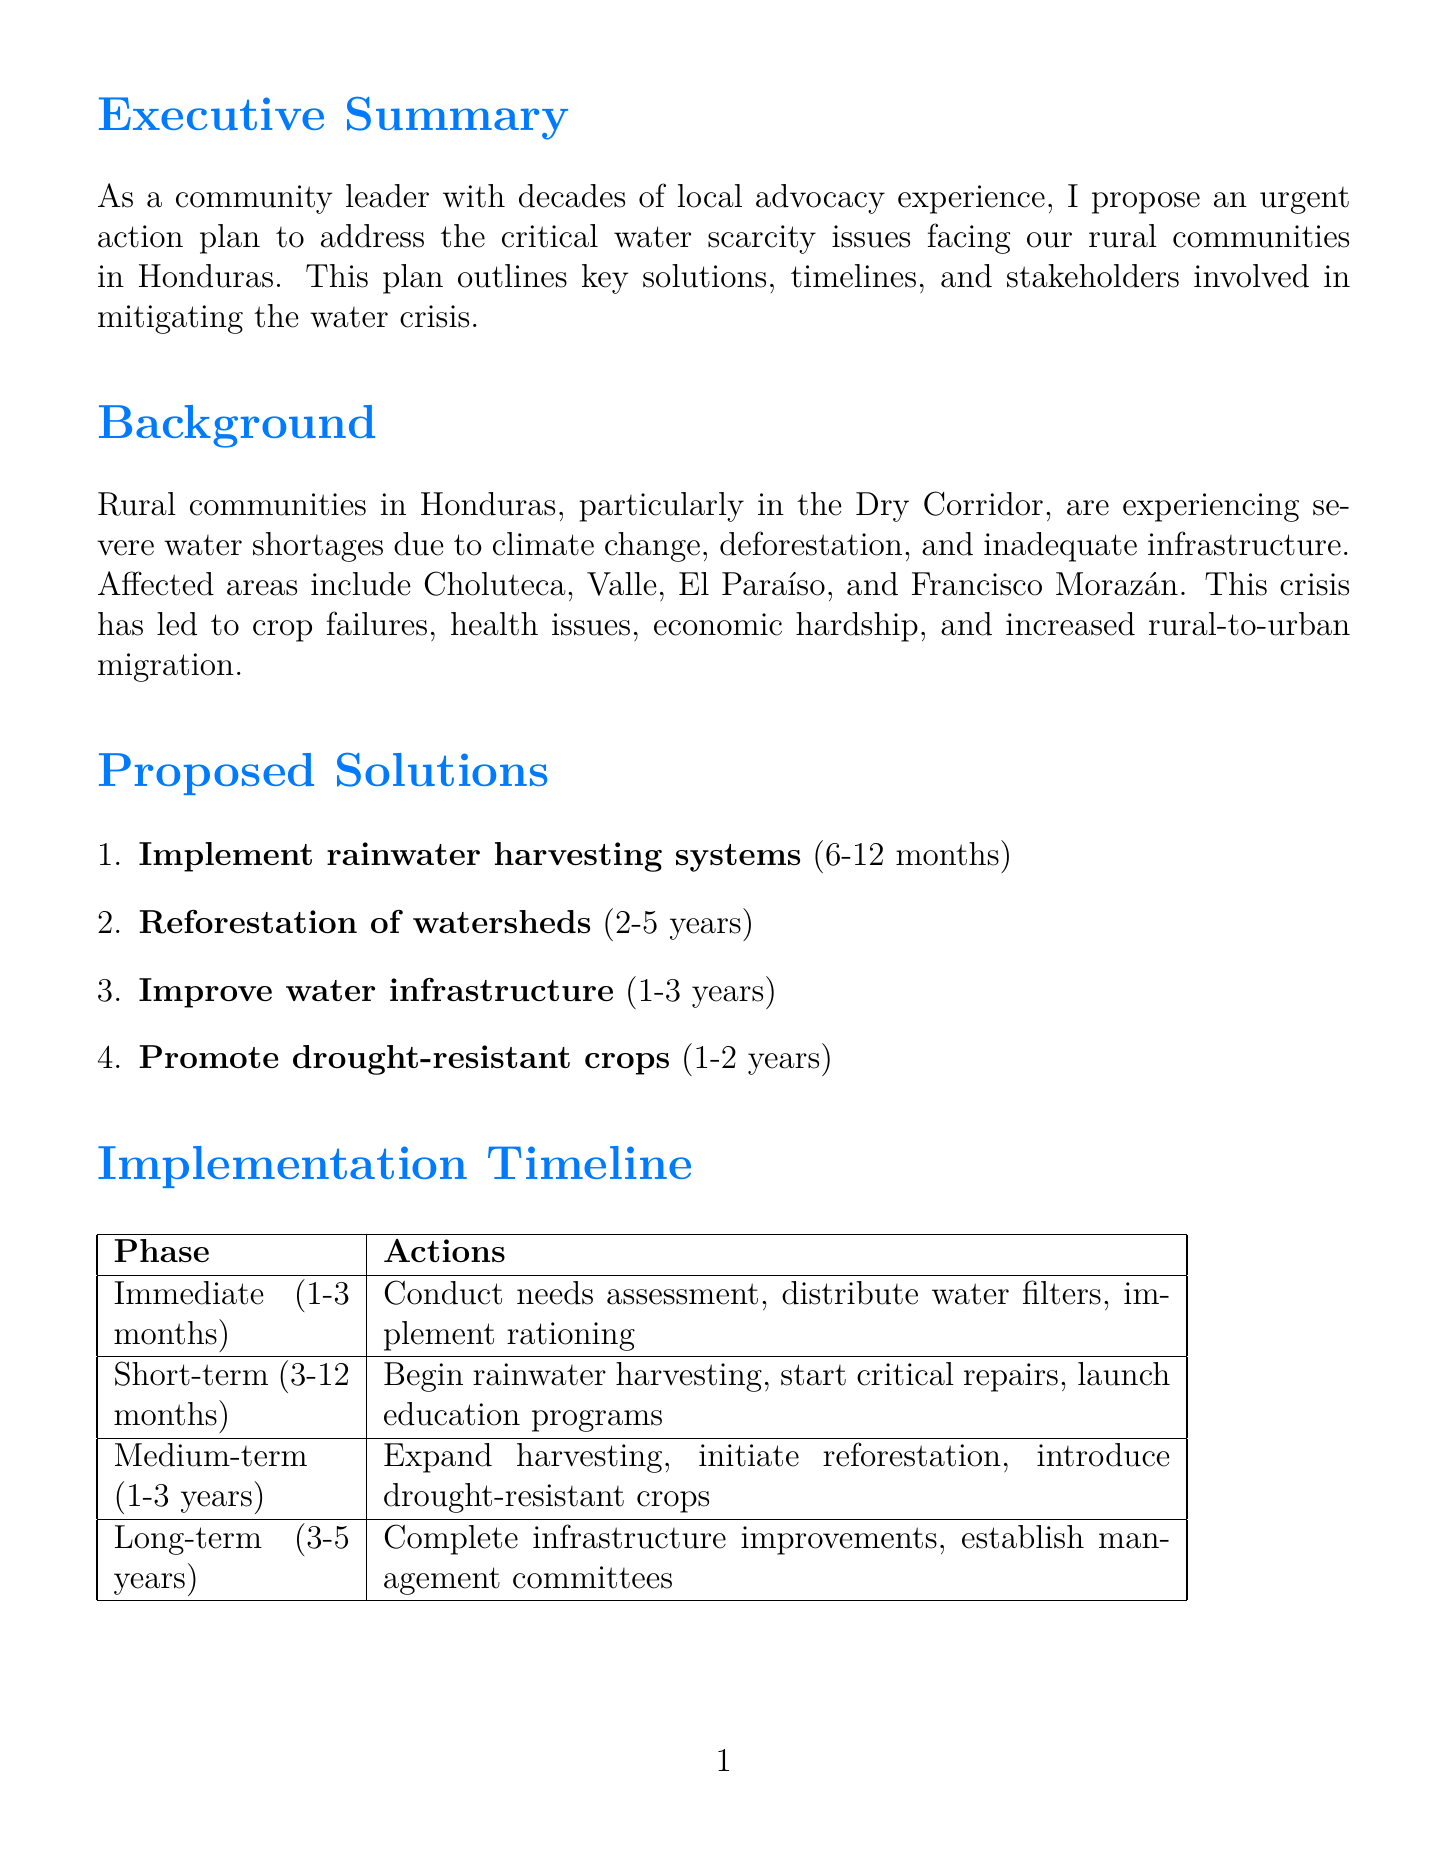What is the primary focus of the action plan? The document outlines key solutions to address the critical water scarcity issues facing rural communities in Honduras.
Answer: Water scarcity Which areas are primarily affected by water scarcity? The document specifically lists Choluteca, Valle, El Paraíso, and Francisco Morazán as the affected areas.
Answer: Choluteca, Valle, El Paraíso, Francisco Morazán How long is the timeline for implementing rainwater harvesting systems? The document states that the timeline for this solution is 6-12 months.
Answer: 6-12 months What are two funding sources mentioned in the document? The memo outlines several funding sources; two of them are the Honduran government budget allocation and the World Bank Water and Sanitation Program.
Answer: Honduran government budget allocation, World Bank Water and Sanitation Program What is the main action in the immediate response phase? The document specifies that conducting a community water needs assessment is one of the main actions in this phase.
Answer: Conduct community water needs assessment How many phases are there in the implementation timeline? The implementation timeline is divided into four distinct phases.
Answer: Four What is the long-term goal of the infrastructure improvements? The memo indicates that the long-term goal is to complete major infrastructure improvements.
Answer: Complete major infrastructure improvements Which stakeholder is involved in promoting drought-resistant crops? The document states that the Secretaría de Agricultura y Ganadería (SAG) is among the stakeholders for this solution.
Answer: Secretaría de Agricultura y Ganadería (SAG) 